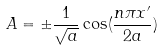Convert formula to latex. <formula><loc_0><loc_0><loc_500><loc_500>A = \pm \frac { 1 } { \sqrt { a } } \cos ( \frac { n \pi x ^ { \prime } } { 2 a } )</formula> 